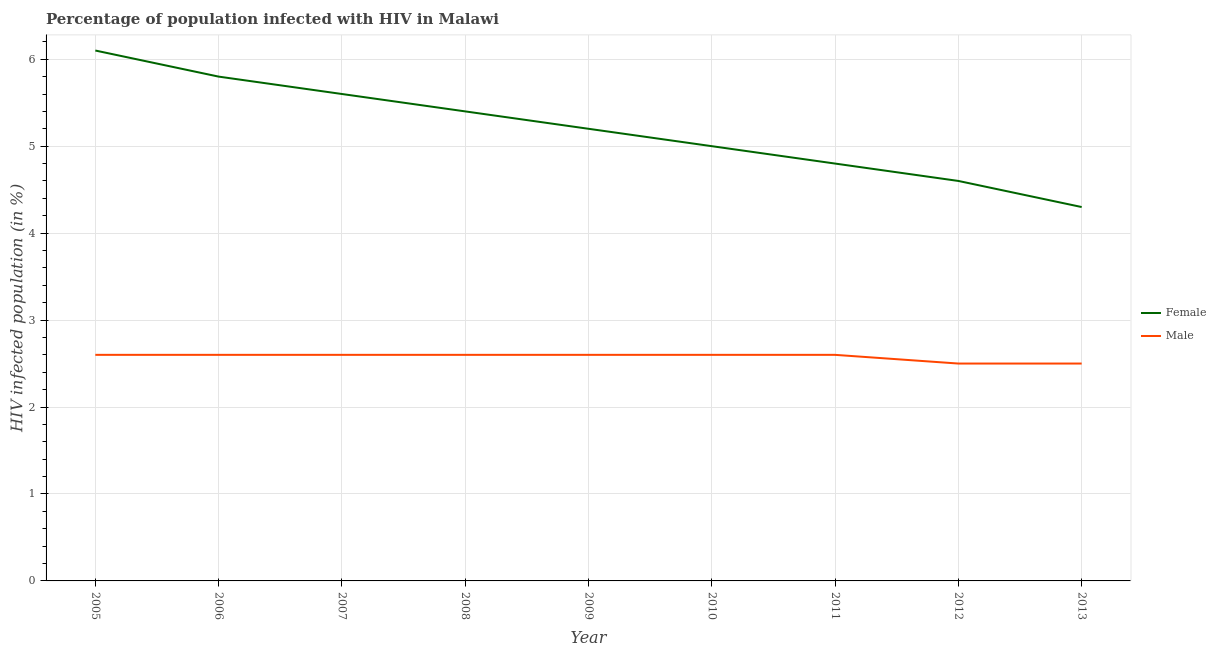How many different coloured lines are there?
Keep it short and to the point. 2. Does the line corresponding to percentage of females who are infected with hiv intersect with the line corresponding to percentage of males who are infected with hiv?
Your response must be concise. No. Is the number of lines equal to the number of legend labels?
Provide a short and direct response. Yes. What is the percentage of males who are infected with hiv in 2008?
Provide a succinct answer. 2.6. Across all years, what is the minimum percentage of males who are infected with hiv?
Ensure brevity in your answer.  2.5. What is the total percentage of females who are infected with hiv in the graph?
Ensure brevity in your answer.  46.8. What is the difference between the percentage of females who are infected with hiv in 2007 and that in 2011?
Offer a terse response. 0.8. What is the difference between the percentage of females who are infected with hiv in 2008 and the percentage of males who are infected with hiv in 2005?
Keep it short and to the point. 2.8. What is the average percentage of males who are infected with hiv per year?
Offer a terse response. 2.58. In the year 2013, what is the difference between the percentage of males who are infected with hiv and percentage of females who are infected with hiv?
Give a very brief answer. -1.8. What is the ratio of the percentage of males who are infected with hiv in 2008 to that in 2010?
Offer a very short reply. 1. Is the difference between the percentage of females who are infected with hiv in 2007 and 2011 greater than the difference between the percentage of males who are infected with hiv in 2007 and 2011?
Keep it short and to the point. Yes. What is the difference between the highest and the lowest percentage of males who are infected with hiv?
Your response must be concise. 0.1. Is the sum of the percentage of females who are infected with hiv in 2007 and 2011 greater than the maximum percentage of males who are infected with hiv across all years?
Offer a terse response. Yes. Does the percentage of females who are infected with hiv monotonically increase over the years?
Your response must be concise. No. Is the percentage of males who are infected with hiv strictly greater than the percentage of females who are infected with hiv over the years?
Your answer should be compact. No. How many lines are there?
Your response must be concise. 2. Are the values on the major ticks of Y-axis written in scientific E-notation?
Ensure brevity in your answer.  No. Where does the legend appear in the graph?
Ensure brevity in your answer.  Center right. How are the legend labels stacked?
Your answer should be compact. Vertical. What is the title of the graph?
Keep it short and to the point. Percentage of population infected with HIV in Malawi. What is the label or title of the X-axis?
Your answer should be very brief. Year. What is the label or title of the Y-axis?
Your response must be concise. HIV infected population (in %). What is the HIV infected population (in %) in Male in 2005?
Offer a terse response. 2.6. What is the HIV infected population (in %) of Female in 2006?
Ensure brevity in your answer.  5.8. What is the HIV infected population (in %) in Male in 2006?
Offer a terse response. 2.6. What is the HIV infected population (in %) in Male in 2007?
Keep it short and to the point. 2.6. What is the HIV infected population (in %) of Female in 2009?
Give a very brief answer. 5.2. What is the HIV infected population (in %) of Male in 2009?
Your answer should be compact. 2.6. What is the HIV infected population (in %) of Female in 2012?
Your answer should be very brief. 4.6. What is the HIV infected population (in %) of Male in 2012?
Offer a very short reply. 2.5. What is the HIV infected population (in %) of Male in 2013?
Provide a succinct answer. 2.5. Across all years, what is the minimum HIV infected population (in %) in Male?
Your answer should be compact. 2.5. What is the total HIV infected population (in %) in Female in the graph?
Your answer should be compact. 46.8. What is the total HIV infected population (in %) of Male in the graph?
Offer a terse response. 23.2. What is the difference between the HIV infected population (in %) in Female in 2005 and that in 2006?
Your answer should be very brief. 0.3. What is the difference between the HIV infected population (in %) in Female in 2005 and that in 2007?
Provide a short and direct response. 0.5. What is the difference between the HIV infected population (in %) in Male in 2005 and that in 2007?
Offer a very short reply. 0. What is the difference between the HIV infected population (in %) of Female in 2005 and that in 2008?
Keep it short and to the point. 0.7. What is the difference between the HIV infected population (in %) of Female in 2005 and that in 2009?
Offer a very short reply. 0.9. What is the difference between the HIV infected population (in %) of Male in 2005 and that in 2009?
Ensure brevity in your answer.  0. What is the difference between the HIV infected population (in %) in Female in 2005 and that in 2010?
Your answer should be very brief. 1.1. What is the difference between the HIV infected population (in %) of Male in 2005 and that in 2010?
Your answer should be compact. 0. What is the difference between the HIV infected population (in %) in Male in 2005 and that in 2012?
Keep it short and to the point. 0.1. What is the difference between the HIV infected population (in %) of Female in 2006 and that in 2009?
Your answer should be very brief. 0.6. What is the difference between the HIV infected population (in %) of Male in 2006 and that in 2009?
Keep it short and to the point. 0. What is the difference between the HIV infected population (in %) of Male in 2006 and that in 2010?
Provide a succinct answer. 0. What is the difference between the HIV infected population (in %) of Female in 2006 and that in 2012?
Make the answer very short. 1.2. What is the difference between the HIV infected population (in %) of Male in 2006 and that in 2013?
Offer a terse response. 0.1. What is the difference between the HIV infected population (in %) in Male in 2007 and that in 2010?
Your response must be concise. 0. What is the difference between the HIV infected population (in %) of Female in 2007 and that in 2012?
Your answer should be compact. 1. What is the difference between the HIV infected population (in %) of Male in 2007 and that in 2012?
Provide a short and direct response. 0.1. What is the difference between the HIV infected population (in %) of Female in 2008 and that in 2009?
Your answer should be compact. 0.2. What is the difference between the HIV infected population (in %) in Female in 2008 and that in 2010?
Give a very brief answer. 0.4. What is the difference between the HIV infected population (in %) of Male in 2008 and that in 2010?
Your response must be concise. 0. What is the difference between the HIV infected population (in %) in Male in 2008 and that in 2011?
Your answer should be compact. 0. What is the difference between the HIV infected population (in %) in Male in 2008 and that in 2012?
Provide a succinct answer. 0.1. What is the difference between the HIV infected population (in %) of Female in 2008 and that in 2013?
Keep it short and to the point. 1.1. What is the difference between the HIV infected population (in %) of Male in 2009 and that in 2010?
Your answer should be very brief. 0. What is the difference between the HIV infected population (in %) of Male in 2009 and that in 2011?
Offer a terse response. 0. What is the difference between the HIV infected population (in %) of Female in 2009 and that in 2012?
Offer a very short reply. 0.6. What is the difference between the HIV infected population (in %) of Male in 2009 and that in 2012?
Offer a very short reply. 0.1. What is the difference between the HIV infected population (in %) of Male in 2009 and that in 2013?
Provide a short and direct response. 0.1. What is the difference between the HIV infected population (in %) of Male in 2010 and that in 2012?
Provide a succinct answer. 0.1. What is the difference between the HIV infected population (in %) in Female in 2010 and that in 2013?
Your answer should be very brief. 0.7. What is the difference between the HIV infected population (in %) of Male in 2011 and that in 2012?
Keep it short and to the point. 0.1. What is the difference between the HIV infected population (in %) of Female in 2011 and that in 2013?
Ensure brevity in your answer.  0.5. What is the difference between the HIV infected population (in %) of Female in 2005 and the HIV infected population (in %) of Male in 2008?
Your answer should be very brief. 3.5. What is the difference between the HIV infected population (in %) in Female in 2005 and the HIV infected population (in %) in Male in 2009?
Ensure brevity in your answer.  3.5. What is the difference between the HIV infected population (in %) of Female in 2005 and the HIV infected population (in %) of Male in 2010?
Provide a succinct answer. 3.5. What is the difference between the HIV infected population (in %) in Female in 2005 and the HIV infected population (in %) in Male in 2012?
Your answer should be compact. 3.6. What is the difference between the HIV infected population (in %) in Female in 2005 and the HIV infected population (in %) in Male in 2013?
Give a very brief answer. 3.6. What is the difference between the HIV infected population (in %) of Female in 2006 and the HIV infected population (in %) of Male in 2007?
Your answer should be very brief. 3.2. What is the difference between the HIV infected population (in %) of Female in 2006 and the HIV infected population (in %) of Male in 2008?
Keep it short and to the point. 3.2. What is the difference between the HIV infected population (in %) in Female in 2006 and the HIV infected population (in %) in Male in 2009?
Make the answer very short. 3.2. What is the difference between the HIV infected population (in %) of Female in 2006 and the HIV infected population (in %) of Male in 2010?
Provide a short and direct response. 3.2. What is the difference between the HIV infected population (in %) in Female in 2006 and the HIV infected population (in %) in Male in 2013?
Keep it short and to the point. 3.3. What is the difference between the HIV infected population (in %) of Female in 2007 and the HIV infected population (in %) of Male in 2011?
Your answer should be very brief. 3. What is the difference between the HIV infected population (in %) in Female in 2008 and the HIV infected population (in %) in Male in 2011?
Make the answer very short. 2.8. What is the difference between the HIV infected population (in %) of Female in 2008 and the HIV infected population (in %) of Male in 2013?
Your answer should be very brief. 2.9. What is the difference between the HIV infected population (in %) in Female in 2009 and the HIV infected population (in %) in Male in 2010?
Provide a short and direct response. 2.6. What is the difference between the HIV infected population (in %) of Female in 2009 and the HIV infected population (in %) of Male in 2011?
Offer a terse response. 2.6. What is the difference between the HIV infected population (in %) in Female in 2010 and the HIV infected population (in %) in Male in 2011?
Your answer should be compact. 2.4. What is the difference between the HIV infected population (in %) of Female in 2010 and the HIV infected population (in %) of Male in 2012?
Keep it short and to the point. 2.5. What is the average HIV infected population (in %) of Female per year?
Offer a very short reply. 5.2. What is the average HIV infected population (in %) of Male per year?
Your response must be concise. 2.58. In the year 2005, what is the difference between the HIV infected population (in %) of Female and HIV infected population (in %) of Male?
Your answer should be very brief. 3.5. In the year 2006, what is the difference between the HIV infected population (in %) of Female and HIV infected population (in %) of Male?
Provide a succinct answer. 3.2. In the year 2008, what is the difference between the HIV infected population (in %) in Female and HIV infected population (in %) in Male?
Provide a succinct answer. 2.8. In the year 2009, what is the difference between the HIV infected population (in %) in Female and HIV infected population (in %) in Male?
Offer a very short reply. 2.6. In the year 2011, what is the difference between the HIV infected population (in %) in Female and HIV infected population (in %) in Male?
Your answer should be very brief. 2.2. In the year 2013, what is the difference between the HIV infected population (in %) in Female and HIV infected population (in %) in Male?
Provide a succinct answer. 1.8. What is the ratio of the HIV infected population (in %) in Female in 2005 to that in 2006?
Your response must be concise. 1.05. What is the ratio of the HIV infected population (in %) of Male in 2005 to that in 2006?
Offer a terse response. 1. What is the ratio of the HIV infected population (in %) in Female in 2005 to that in 2007?
Make the answer very short. 1.09. What is the ratio of the HIV infected population (in %) of Male in 2005 to that in 2007?
Give a very brief answer. 1. What is the ratio of the HIV infected population (in %) of Female in 2005 to that in 2008?
Make the answer very short. 1.13. What is the ratio of the HIV infected population (in %) of Male in 2005 to that in 2008?
Provide a succinct answer. 1. What is the ratio of the HIV infected population (in %) in Female in 2005 to that in 2009?
Offer a terse response. 1.17. What is the ratio of the HIV infected population (in %) of Male in 2005 to that in 2009?
Your answer should be very brief. 1. What is the ratio of the HIV infected population (in %) of Female in 2005 to that in 2010?
Provide a succinct answer. 1.22. What is the ratio of the HIV infected population (in %) in Female in 2005 to that in 2011?
Give a very brief answer. 1.27. What is the ratio of the HIV infected population (in %) in Male in 2005 to that in 2011?
Make the answer very short. 1. What is the ratio of the HIV infected population (in %) in Female in 2005 to that in 2012?
Offer a terse response. 1.33. What is the ratio of the HIV infected population (in %) in Female in 2005 to that in 2013?
Keep it short and to the point. 1.42. What is the ratio of the HIV infected population (in %) of Male in 2005 to that in 2013?
Offer a very short reply. 1.04. What is the ratio of the HIV infected population (in %) in Female in 2006 to that in 2007?
Your answer should be very brief. 1.04. What is the ratio of the HIV infected population (in %) of Female in 2006 to that in 2008?
Provide a succinct answer. 1.07. What is the ratio of the HIV infected population (in %) of Male in 2006 to that in 2008?
Your answer should be very brief. 1. What is the ratio of the HIV infected population (in %) of Female in 2006 to that in 2009?
Ensure brevity in your answer.  1.12. What is the ratio of the HIV infected population (in %) of Female in 2006 to that in 2010?
Your answer should be very brief. 1.16. What is the ratio of the HIV infected population (in %) in Female in 2006 to that in 2011?
Provide a short and direct response. 1.21. What is the ratio of the HIV infected population (in %) of Male in 2006 to that in 2011?
Provide a succinct answer. 1. What is the ratio of the HIV infected population (in %) of Female in 2006 to that in 2012?
Provide a short and direct response. 1.26. What is the ratio of the HIV infected population (in %) of Male in 2006 to that in 2012?
Make the answer very short. 1.04. What is the ratio of the HIV infected population (in %) of Female in 2006 to that in 2013?
Your answer should be very brief. 1.35. What is the ratio of the HIV infected population (in %) in Female in 2007 to that in 2010?
Offer a terse response. 1.12. What is the ratio of the HIV infected population (in %) in Male in 2007 to that in 2010?
Your answer should be compact. 1. What is the ratio of the HIV infected population (in %) in Female in 2007 to that in 2012?
Provide a short and direct response. 1.22. What is the ratio of the HIV infected population (in %) of Male in 2007 to that in 2012?
Provide a short and direct response. 1.04. What is the ratio of the HIV infected population (in %) of Female in 2007 to that in 2013?
Your answer should be compact. 1.3. What is the ratio of the HIV infected population (in %) of Female in 2008 to that in 2009?
Your response must be concise. 1.04. What is the ratio of the HIV infected population (in %) in Female in 2008 to that in 2010?
Give a very brief answer. 1.08. What is the ratio of the HIV infected population (in %) in Female in 2008 to that in 2011?
Ensure brevity in your answer.  1.12. What is the ratio of the HIV infected population (in %) in Female in 2008 to that in 2012?
Offer a terse response. 1.17. What is the ratio of the HIV infected population (in %) in Female in 2008 to that in 2013?
Provide a short and direct response. 1.26. What is the ratio of the HIV infected population (in %) of Female in 2009 to that in 2010?
Give a very brief answer. 1.04. What is the ratio of the HIV infected population (in %) in Female in 2009 to that in 2012?
Give a very brief answer. 1.13. What is the ratio of the HIV infected population (in %) of Male in 2009 to that in 2012?
Ensure brevity in your answer.  1.04. What is the ratio of the HIV infected population (in %) of Female in 2009 to that in 2013?
Your answer should be compact. 1.21. What is the ratio of the HIV infected population (in %) of Male in 2009 to that in 2013?
Make the answer very short. 1.04. What is the ratio of the HIV infected population (in %) of Female in 2010 to that in 2011?
Offer a terse response. 1.04. What is the ratio of the HIV infected population (in %) of Female in 2010 to that in 2012?
Your answer should be compact. 1.09. What is the ratio of the HIV infected population (in %) in Male in 2010 to that in 2012?
Offer a terse response. 1.04. What is the ratio of the HIV infected population (in %) of Female in 2010 to that in 2013?
Your response must be concise. 1.16. What is the ratio of the HIV infected population (in %) of Female in 2011 to that in 2012?
Your answer should be compact. 1.04. What is the ratio of the HIV infected population (in %) in Female in 2011 to that in 2013?
Your answer should be very brief. 1.12. What is the ratio of the HIV infected population (in %) in Female in 2012 to that in 2013?
Offer a very short reply. 1.07. What is the ratio of the HIV infected population (in %) in Male in 2012 to that in 2013?
Give a very brief answer. 1. What is the difference between the highest and the second highest HIV infected population (in %) of Male?
Provide a short and direct response. 0. 